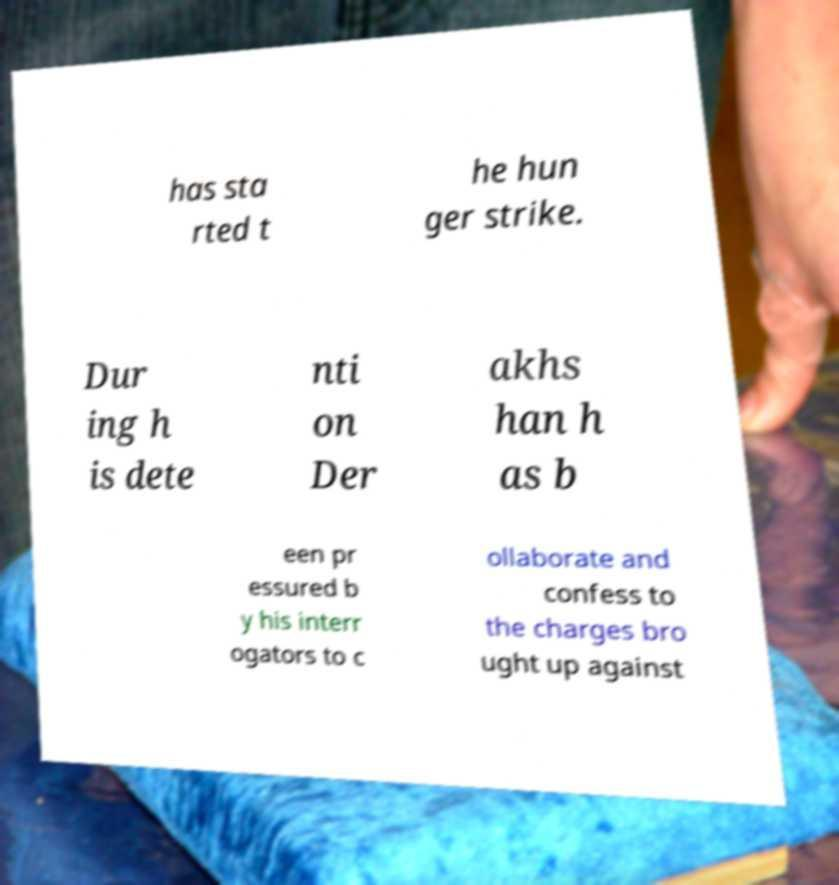Please identify and transcribe the text found in this image. has sta rted t he hun ger strike. Dur ing h is dete nti on Der akhs han h as b een pr essured b y his interr ogators to c ollaborate and confess to the charges bro ught up against 